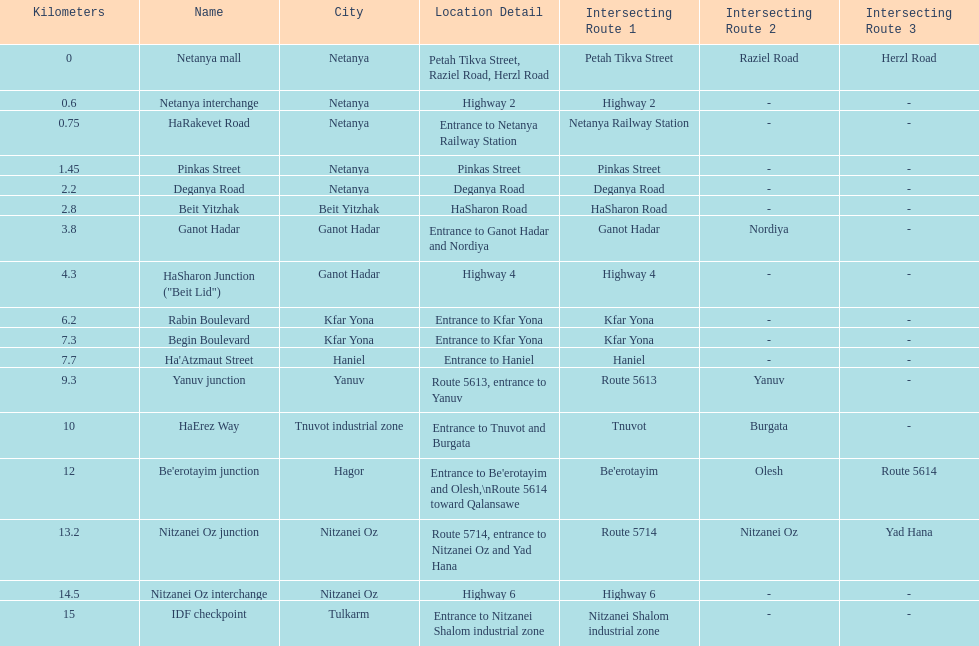How many portions are lo?cated in netanya 5. 